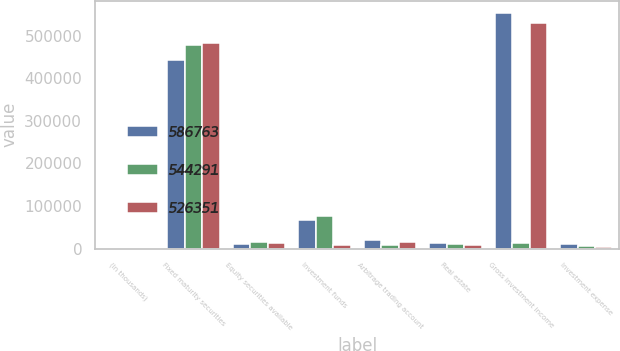<chart> <loc_0><loc_0><loc_500><loc_500><stacked_bar_chart><ecel><fcel>(In thousands)<fcel>Fixed maturity securities<fcel>Equity securities available<fcel>Investment funds<fcel>Arbitrage trading account<fcel>Real estate<fcel>Gross investment income<fcel>Investment expense<nl><fcel>586763<fcel>2013<fcel>442287<fcel>11380<fcel>67712<fcel>20431<fcel>12498<fcel>554308<fcel>10017<nl><fcel>544291<fcel>2012<fcel>479035<fcel>16419<fcel>77015<fcel>8286<fcel>12097<fcel>12416<fcel>6089<nl><fcel>526351<fcel>2011<fcel>483905<fcel>12416<fcel>9452<fcel>16576<fcel>7471<fcel>529820<fcel>3469<nl></chart> 